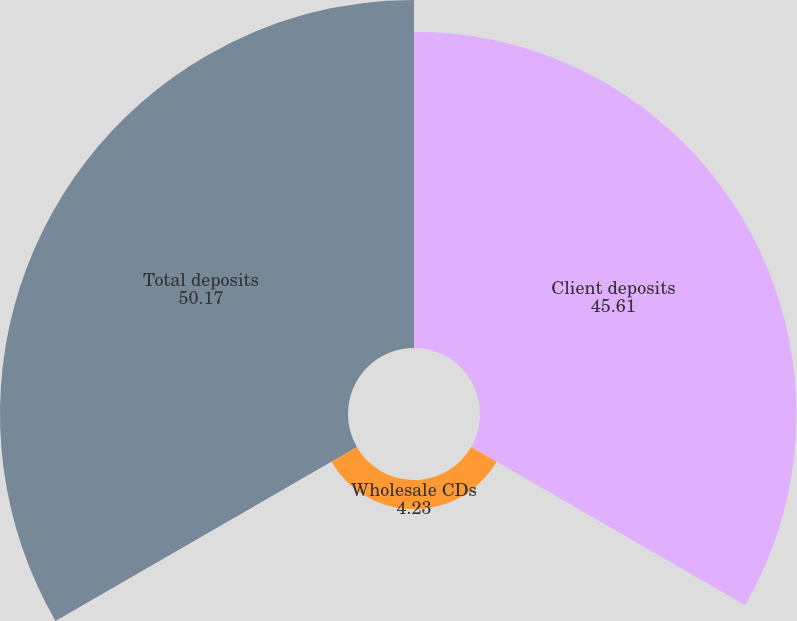Convert chart to OTSL. <chart><loc_0><loc_0><loc_500><loc_500><pie_chart><fcel>Client deposits<fcel>Wholesale CDs<fcel>Total deposits<nl><fcel>45.61%<fcel>4.23%<fcel>50.17%<nl></chart> 